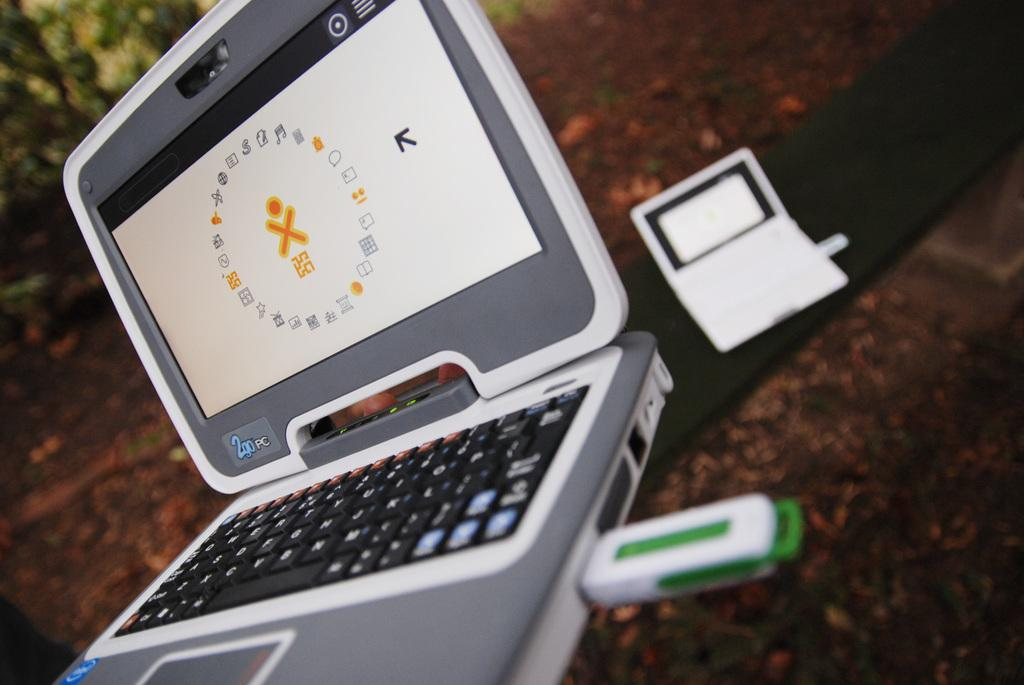<image>
Describe the image concisely. Compact laptop that is called a 2go PC and has a thumb drive installed on side. 